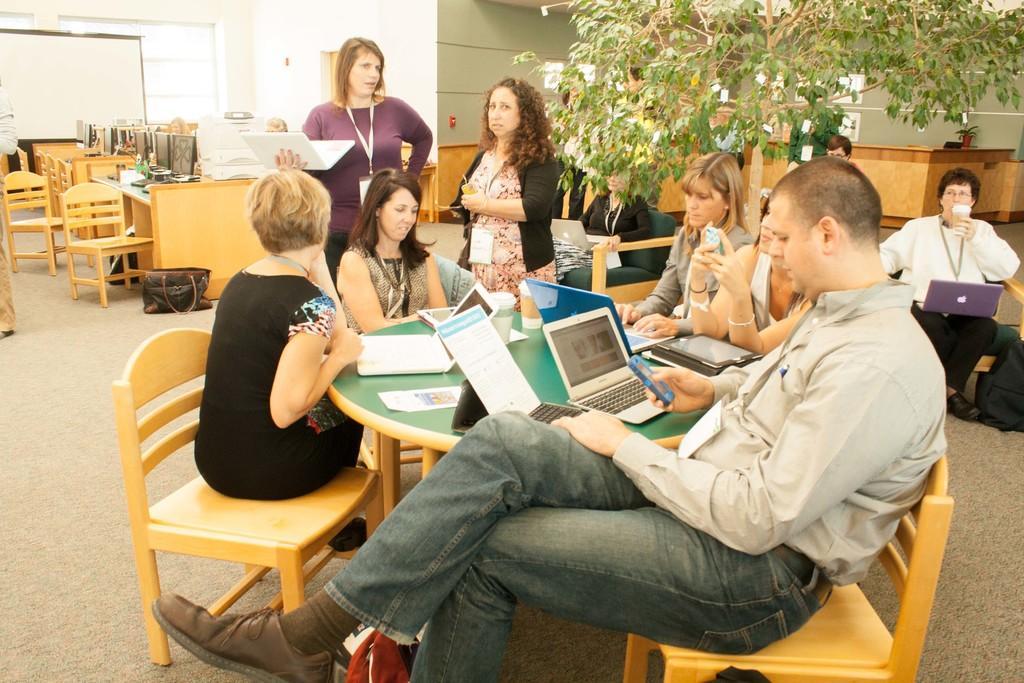Describe this image in one or two sentences. The picture looks like an office space. In the center of the image of the foreground there is a table and chairs, around the table there are employees standing and sitting discussing. On the table there are laptops, papers. On the left there are many PCs, chairs, tables. To the top left there is a board, beside there is a window. On the top right there is a plant. On the right there is a woman seated drinking. On the top right there is a desk. On the top left there is a person standing. 